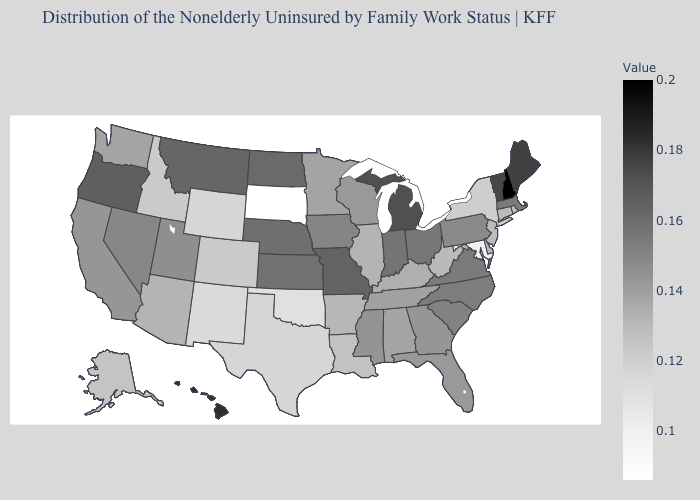Among the states that border New Hampshire , does Vermont have the lowest value?
Keep it brief. No. Among the states that border New York , does Massachusetts have the lowest value?
Concise answer only. No. Does New Hampshire have the highest value in the USA?
Quick response, please. Yes. Does Connecticut have a higher value than Pennsylvania?
Quick response, please. No. Does Hawaii have the highest value in the West?
Give a very brief answer. Yes. Is the legend a continuous bar?
Give a very brief answer. Yes. Among the states that border Oklahoma , which have the lowest value?
Quick response, please. New Mexico. Is the legend a continuous bar?
Keep it brief. Yes. 